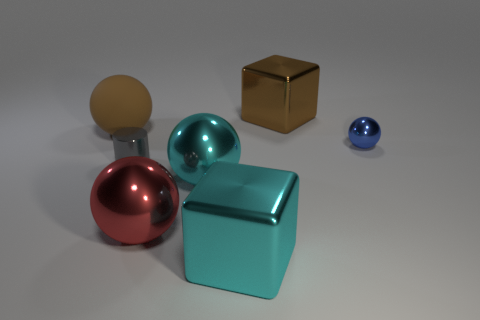Add 1 large red spheres. How many objects exist? 8 Subtract all cylinders. How many objects are left? 6 Subtract all gray cylinders. Subtract all gray things. How many objects are left? 5 Add 6 small metallic cylinders. How many small metallic cylinders are left? 7 Add 3 cubes. How many cubes exist? 5 Subtract 0 green blocks. How many objects are left? 7 